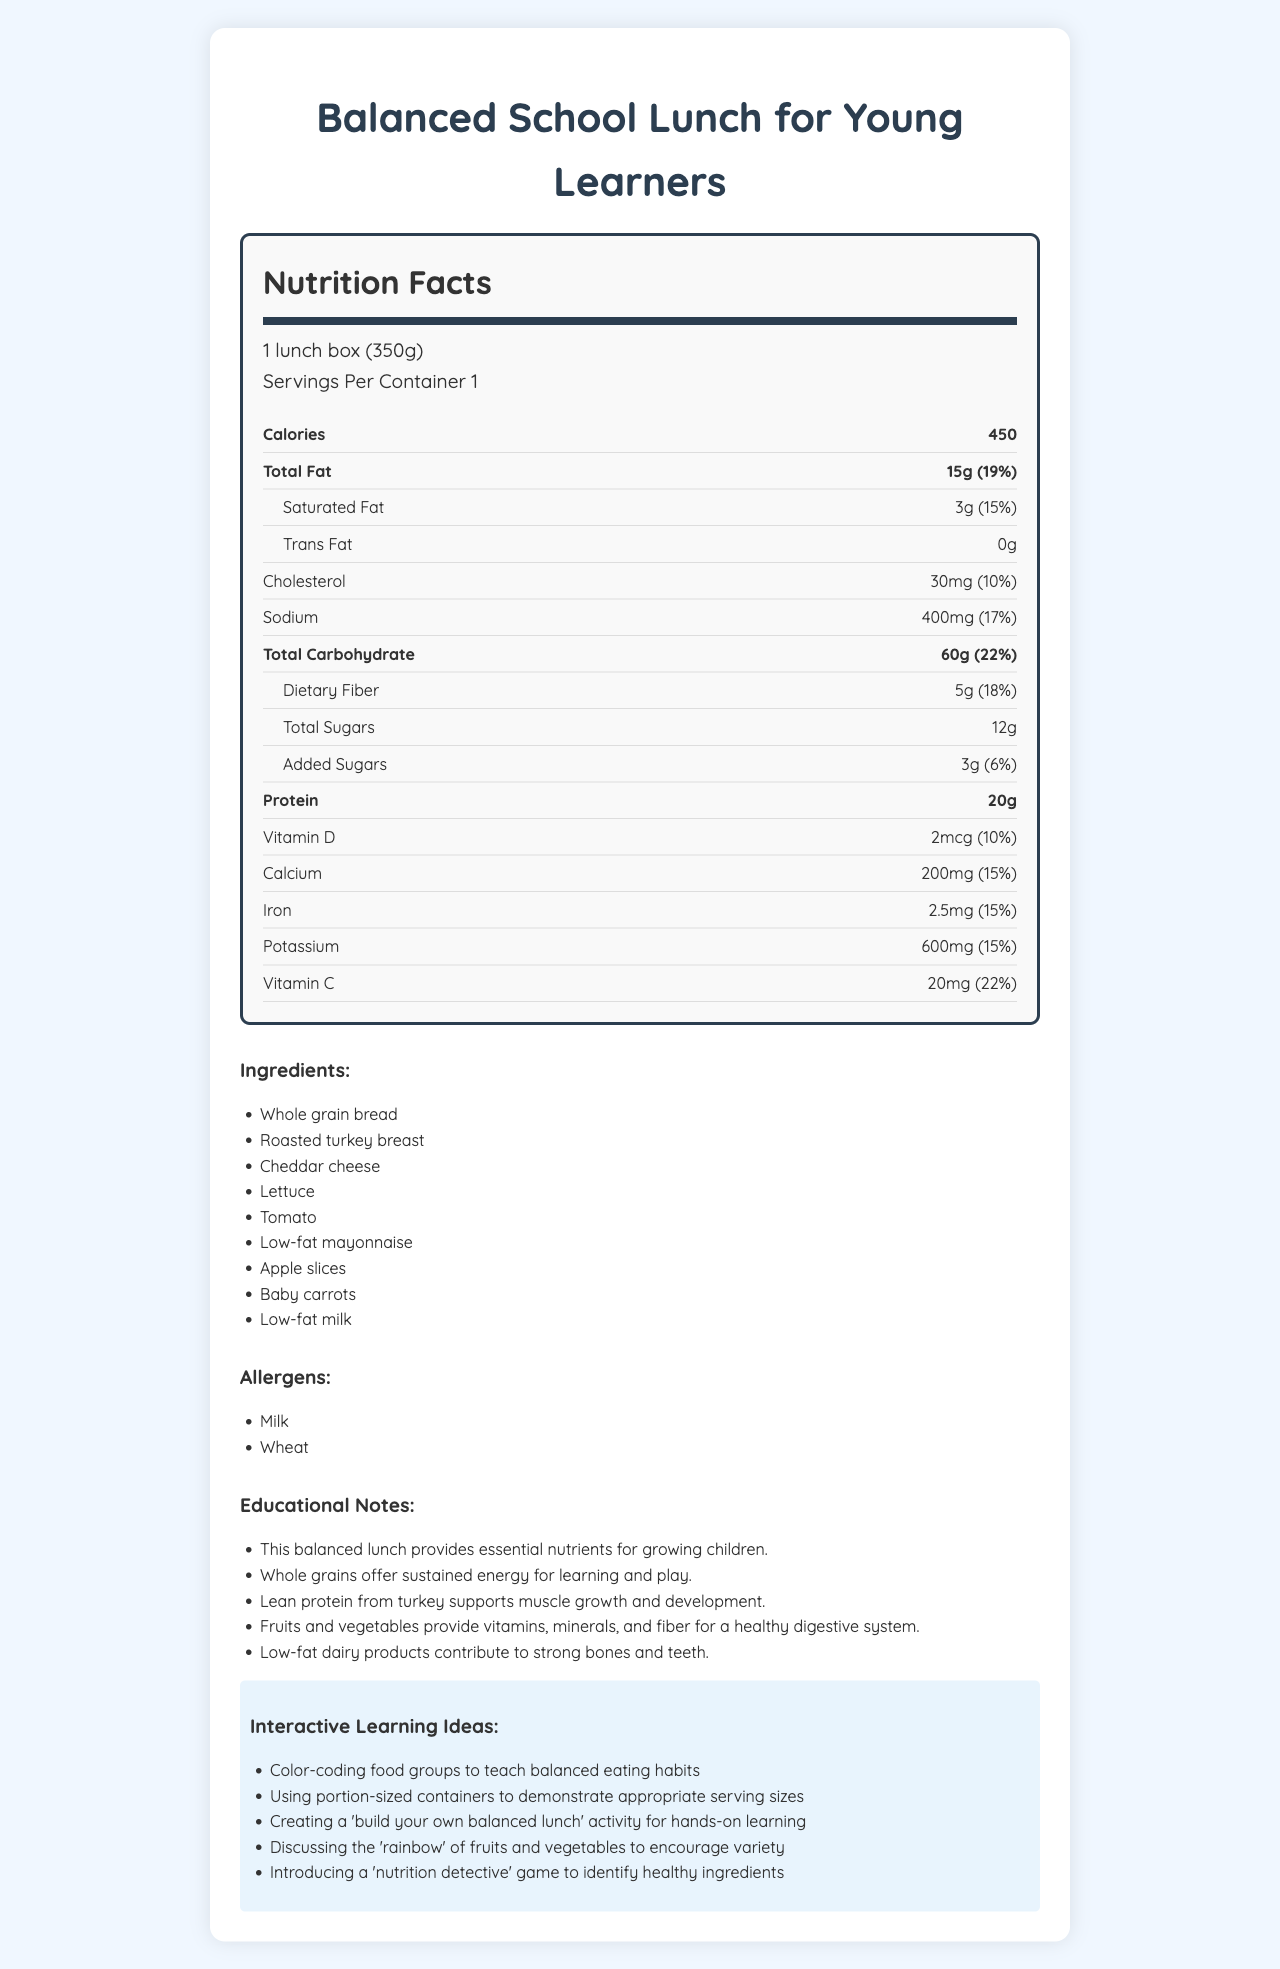what is the serving size for the balanced school lunch? The serving size is stated near the top of the Nutrition Facts label, indicating it is 1 lunch box weighing 350 grams.
Answer: 1 lunch box (350g) how many calories are in one serving? The calorie content is prominently listed in the middle of the Nutrition Facts label, showing 450 calories.
Answer: 450 which ingredient is a source of lean protein? Lean protein from turkey is specifically mentioned in the ingredients list and supported by the educational notes pointing out its benefits.
Answer: Roasted turkey breast how much dietary fiber does the lunch provide? The dietary fiber content is specified in the Nutrition Facts label indicating it provides 5 grams of dietary fiber.
Answer: 5g how can you teach balanced eating habits using this lunch? One of the interactive learning ideas suggested in the document is using color-coding food groups to teach balanced eating habits.
Answer: Color-coding food groups what percentage of the daily value of calcium does the lunch provide? A. 10% B. 15% C. 22% D. 18% The Nutrition Facts label states that the calcium content is 200mg, which is 15% of the daily value.
Answer: B which of the following is an allergen present in the lunch? I. Milk II. Eggs III. Wheat The document lists milk and wheat as allergens, but not eggs.
Answer: I and III is trans fat included in the lunch? The Nutrition Facts label states that the trans fat content is 0g, indicating there is no trans fat in the lunch.
Answer: No does this lunch include any added sugars? The Nutrition Facts label details that there are 3 grams of added sugars, which is 6% of the daily value.
Answer: Yes how does this meal contribute to a child's bone health? The educational notes section explains that low-fat dairy products in the lunch help contribute to strong bones and teeth.
Answer: Low-fat dairy products contribute to strong bones and teeth. describe the main components of the balanced school lunch document. The document contains a nutritional breakdown of the lunch, lists of ingredients and allergens, educational notes to emphasize the health benefits, and interactive ideas to help teach children about nutrition.
Answer: The balanced school lunch document includes a detailed Nutrition Facts label providing information on calories, fats, cholesterol, sodium, carbohydrates, proteins, and various vitamins and minerals. It lists the ingredients and allergens, provides educational notes on the nutritional benefits for growing children, and suggests interactive learning ideas to teach balanced eating habits. how many servings are there per container? The document states that there is 1 serving per container, as noted in the serving information.
Answer: 1 how much sodium does one serving contain? The Nutrition Facts label lists the sodium content as 400mg, which is 17% of the daily value.
Answer: 400mg can you determine the exact recipe for the lunch box from this document? The document provides a list of ingredients but does not specify the exact quantities or instructions needed to recreate the lunch box recipe.
Answer: Cannot be determined 